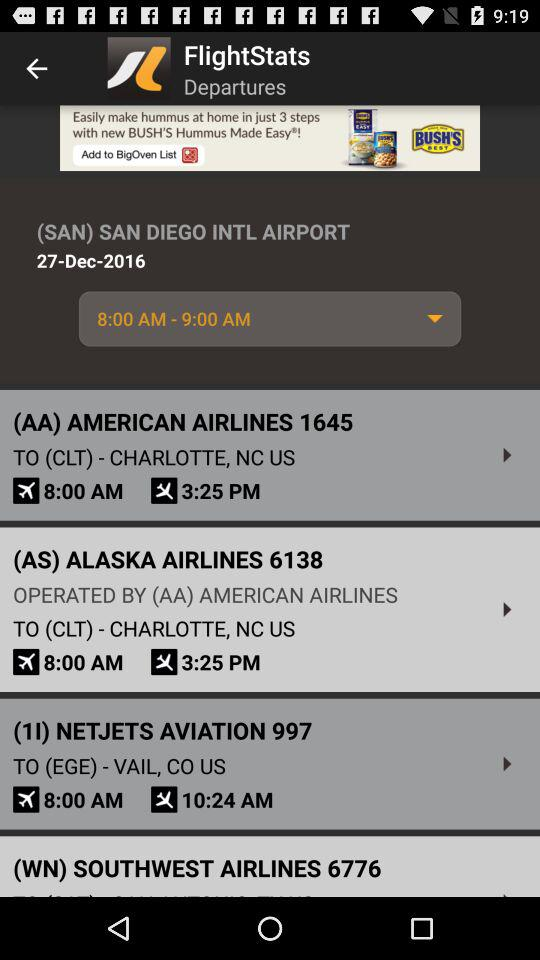What is the flight number of "Alaska Airlines"? The flight number of "Alaska Airlines" is 6138. 